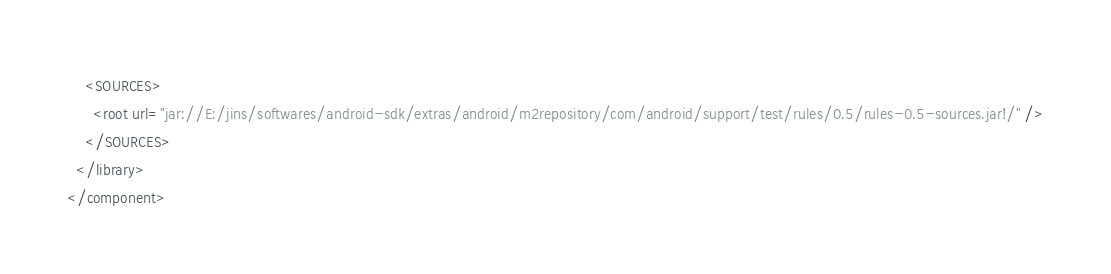Convert code to text. <code><loc_0><loc_0><loc_500><loc_500><_XML_>    <SOURCES>
      <root url="jar://E:/jins/softwares/android-sdk/extras/android/m2repository/com/android/support/test/rules/0.5/rules-0.5-sources.jar!/" />
    </SOURCES>
  </library>
</component></code> 